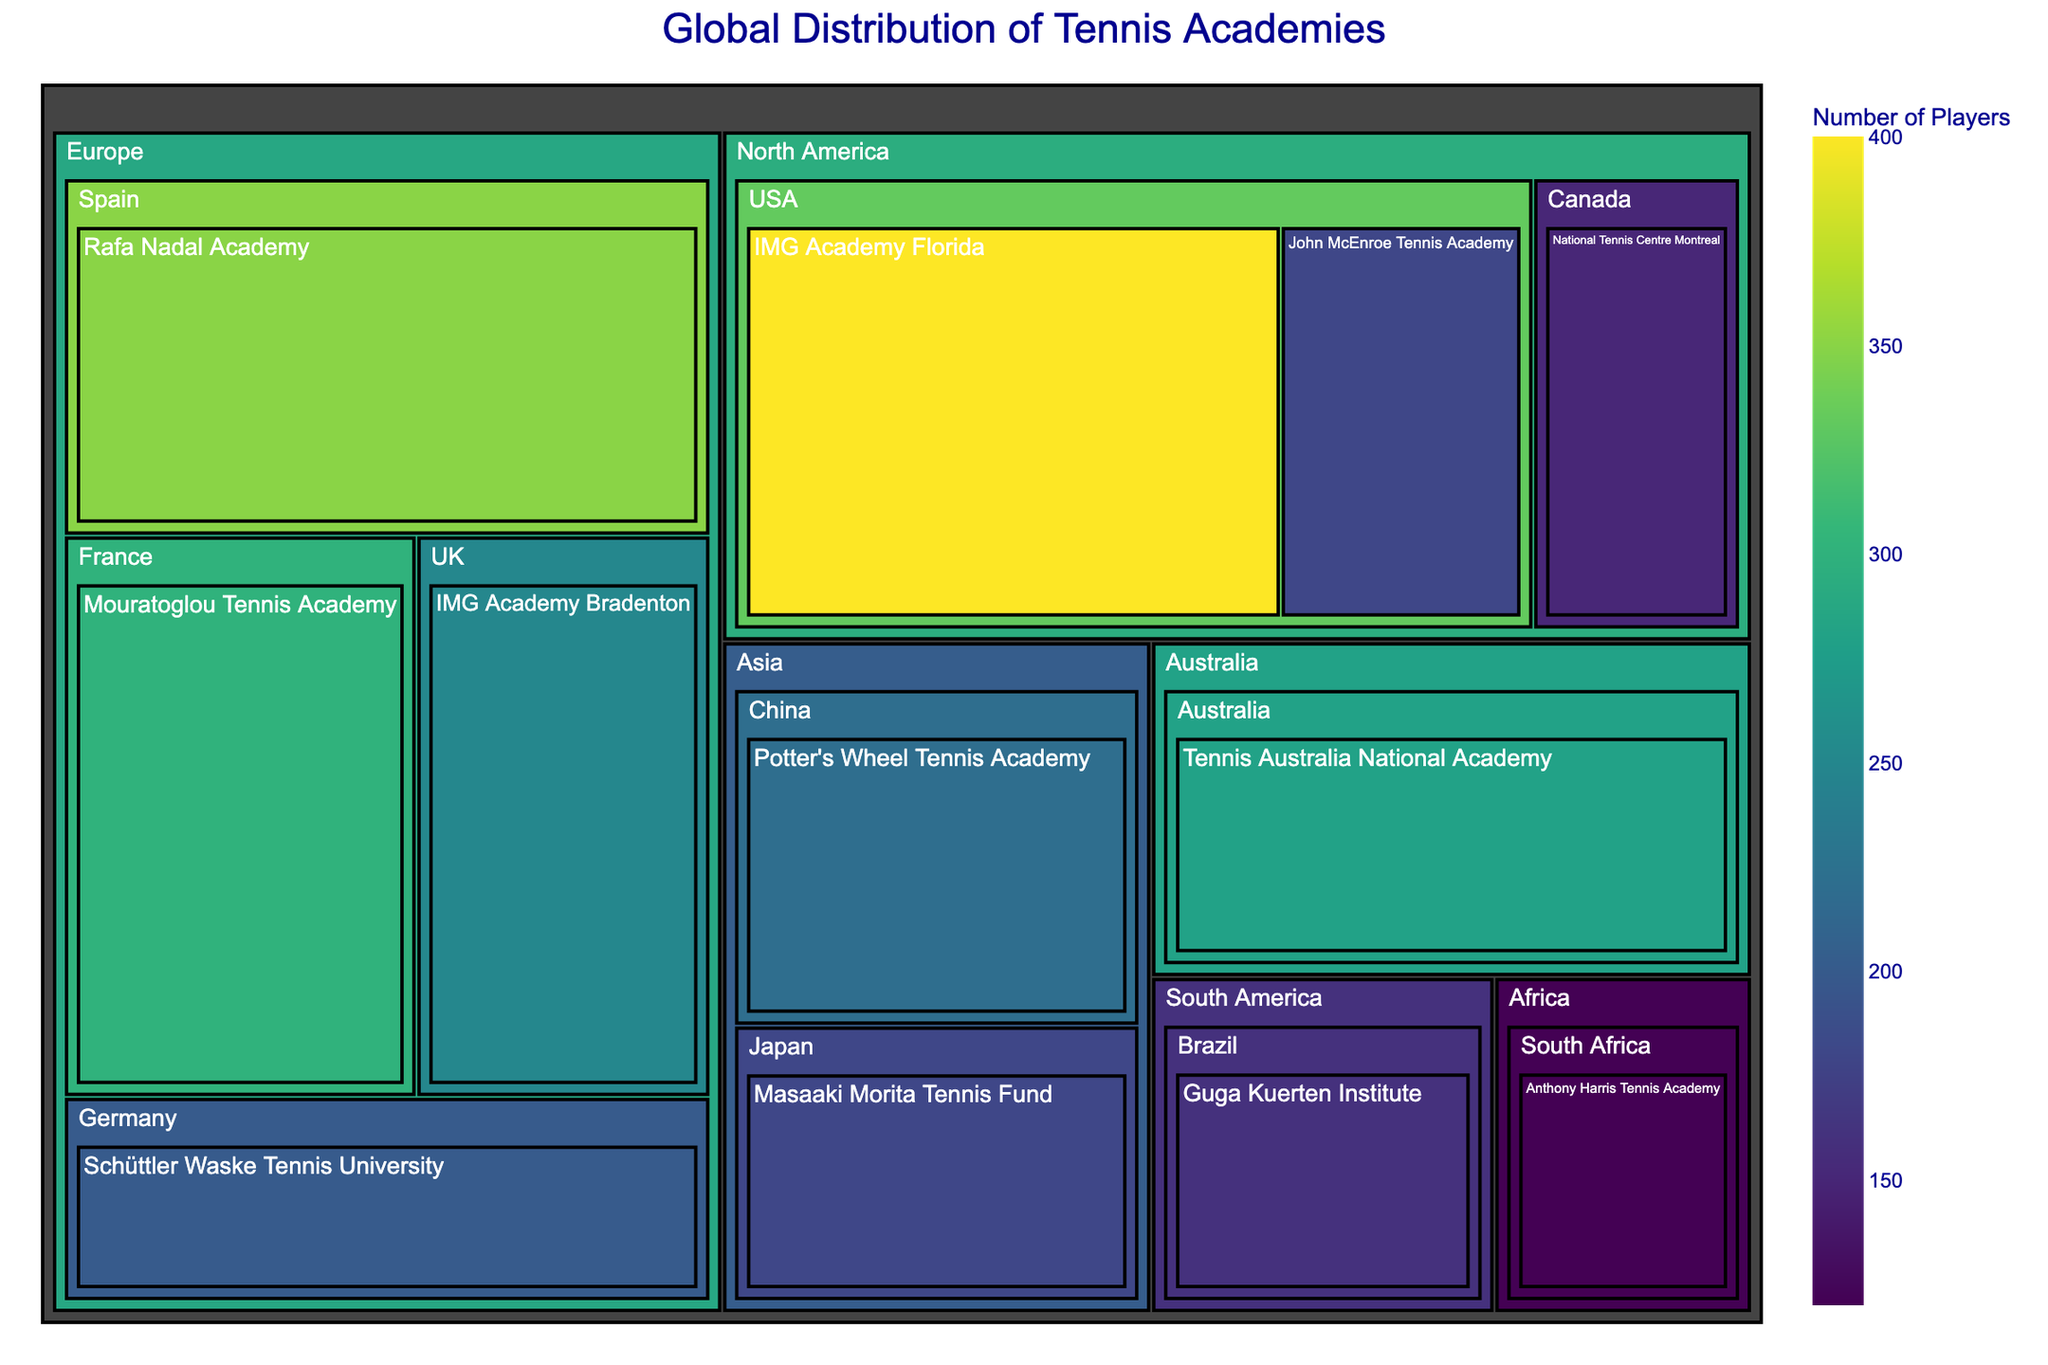what is the academy with the highest number of players? The color and size of the boxes represent the number of players; the largest and darkest box is "IMG Academy Florida".
Answer: IMG Academy Florida Which country in North America has the most tennis academies listed? The map reveals that the USA has two tennis academies listed: "IMG Academy Florida" and "John McEnroe Tennis Academy", whereas Canada has only one.
Answer: USA How many regions have tennis academies listed in the treemap? The treemap data includes five regions: Europe, North America, Asia, Australia, South America, and Africa.
Answer: 6 Which region has the largest total number of players across all its academies? Summing up the players for each academy in the regions, Europe has the most: Rafa Nadal (350), Mouratoglou (300), Schüttler Waske (200), and IMG Academy Bradenton (250). Total: 350 + 300 + 200 + 250 = 1100.
Answer: Europe Which region's academy has the smallest number of players? The "Anthony Harris Tennis Academy" in South Africa as the smallest box, indicating it has the least number of players, which is 120.
Answer: Africa How does Australia compare to Brazil in terms of total number of players in their academies? Australia's "Tennis Australia National Academy" has 280 players, whereas Brazil's "Guga Kuerten Institute" has 160 players. So, Australia has more players.
Answer: Australia has more players What is the most represented country in terms of the number of academies listed? The USA has the largest number of academies listed, with two: "IMG Academy Florida" and "John McEnroe Tennis Academy".
Answer: USA What's the difference in the number of players between Rafa Nadal Academy and Tennis Australia National Academy? Rafa Nadal Academy has 350 players, and Tennis Australia National Academy has 280 players. The difference is 350 - 280 = 70.
Answer: 70 Identify the academy with the second highest number of players in North America. In North America, "IMG Academy Florida" has the highest number of players (400), followed by "John McEnroe Tennis Academy" with 180 players.
Answer: John McEnroe Tennis Academy 